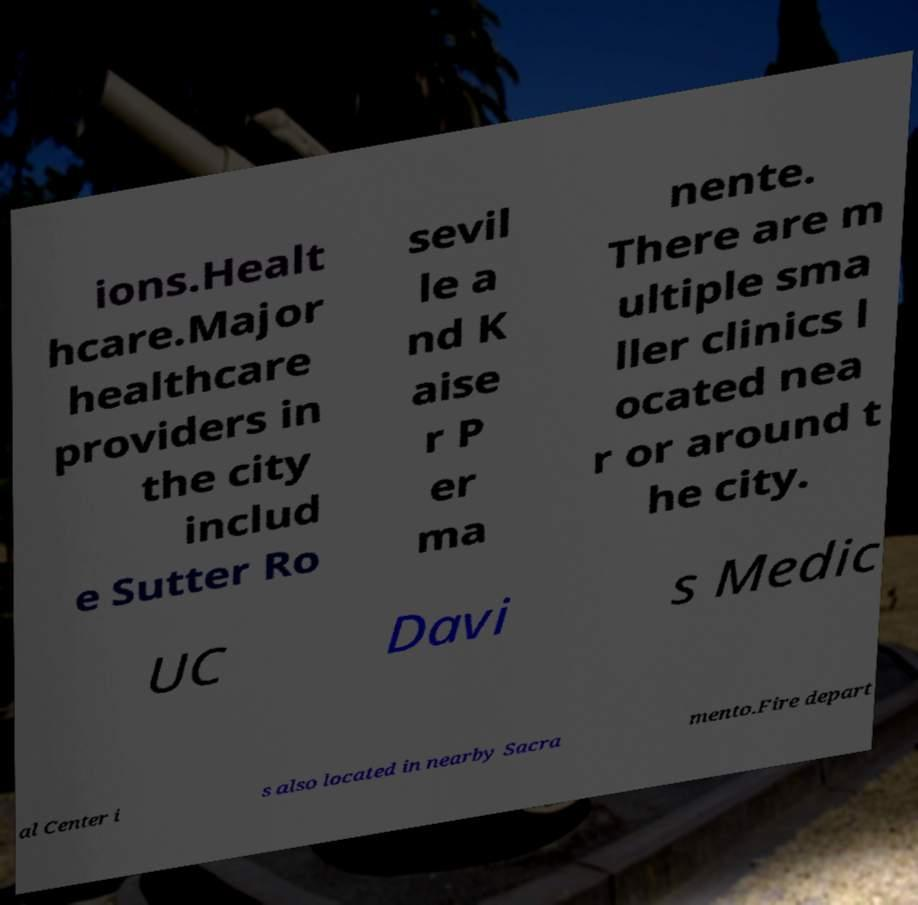Please read and relay the text visible in this image. What does it say? ions.Healt hcare.Major healthcare providers in the city includ e Sutter Ro sevil le a nd K aise r P er ma nente. There are m ultiple sma ller clinics l ocated nea r or around t he city. UC Davi s Medic al Center i s also located in nearby Sacra mento.Fire depart 